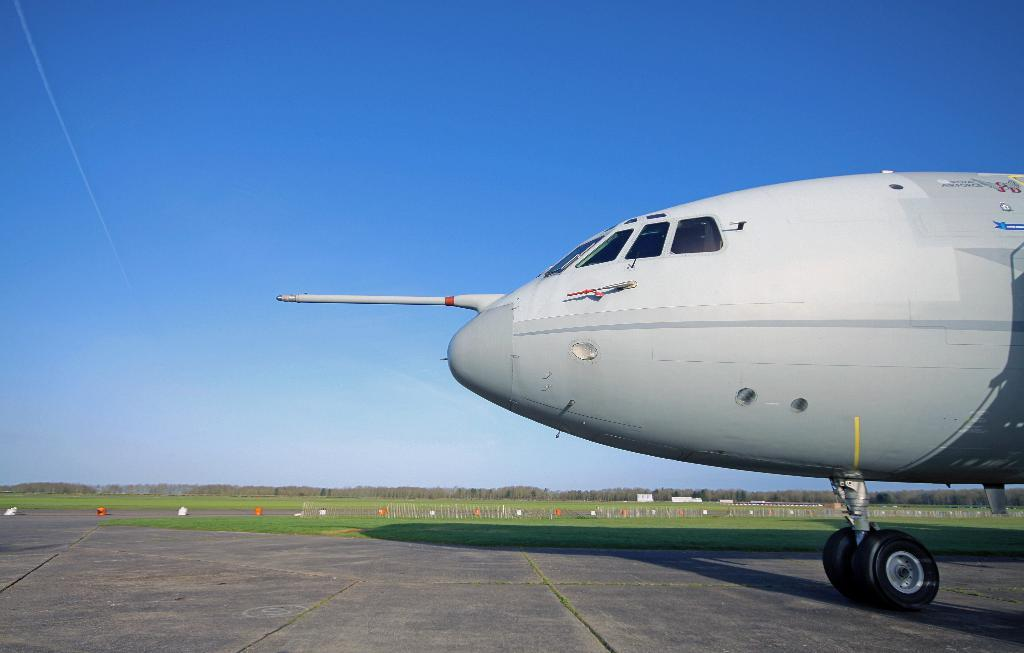What is the main subject of the image? The main subject of the image is an aeroplane. Where is the aeroplane located in the image? The aeroplane is on the land in the image. What can be seen in the background of the image? There is greenery and the sky visible in the background of the image. Can you see any yaks or squirrels in the image? No, there are no yaks or squirrels present in the image. 